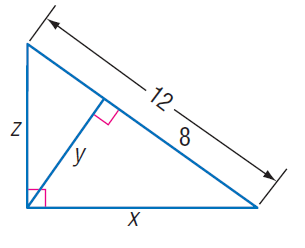Answer the mathemtical geometry problem and directly provide the correct option letter.
Question: Find z.
Choices: A: 2 \sqrt { 3 } B: 2 \sqrt { 6 } C: 4 \sqrt { 3 } D: 4 \sqrt { 6 } C 